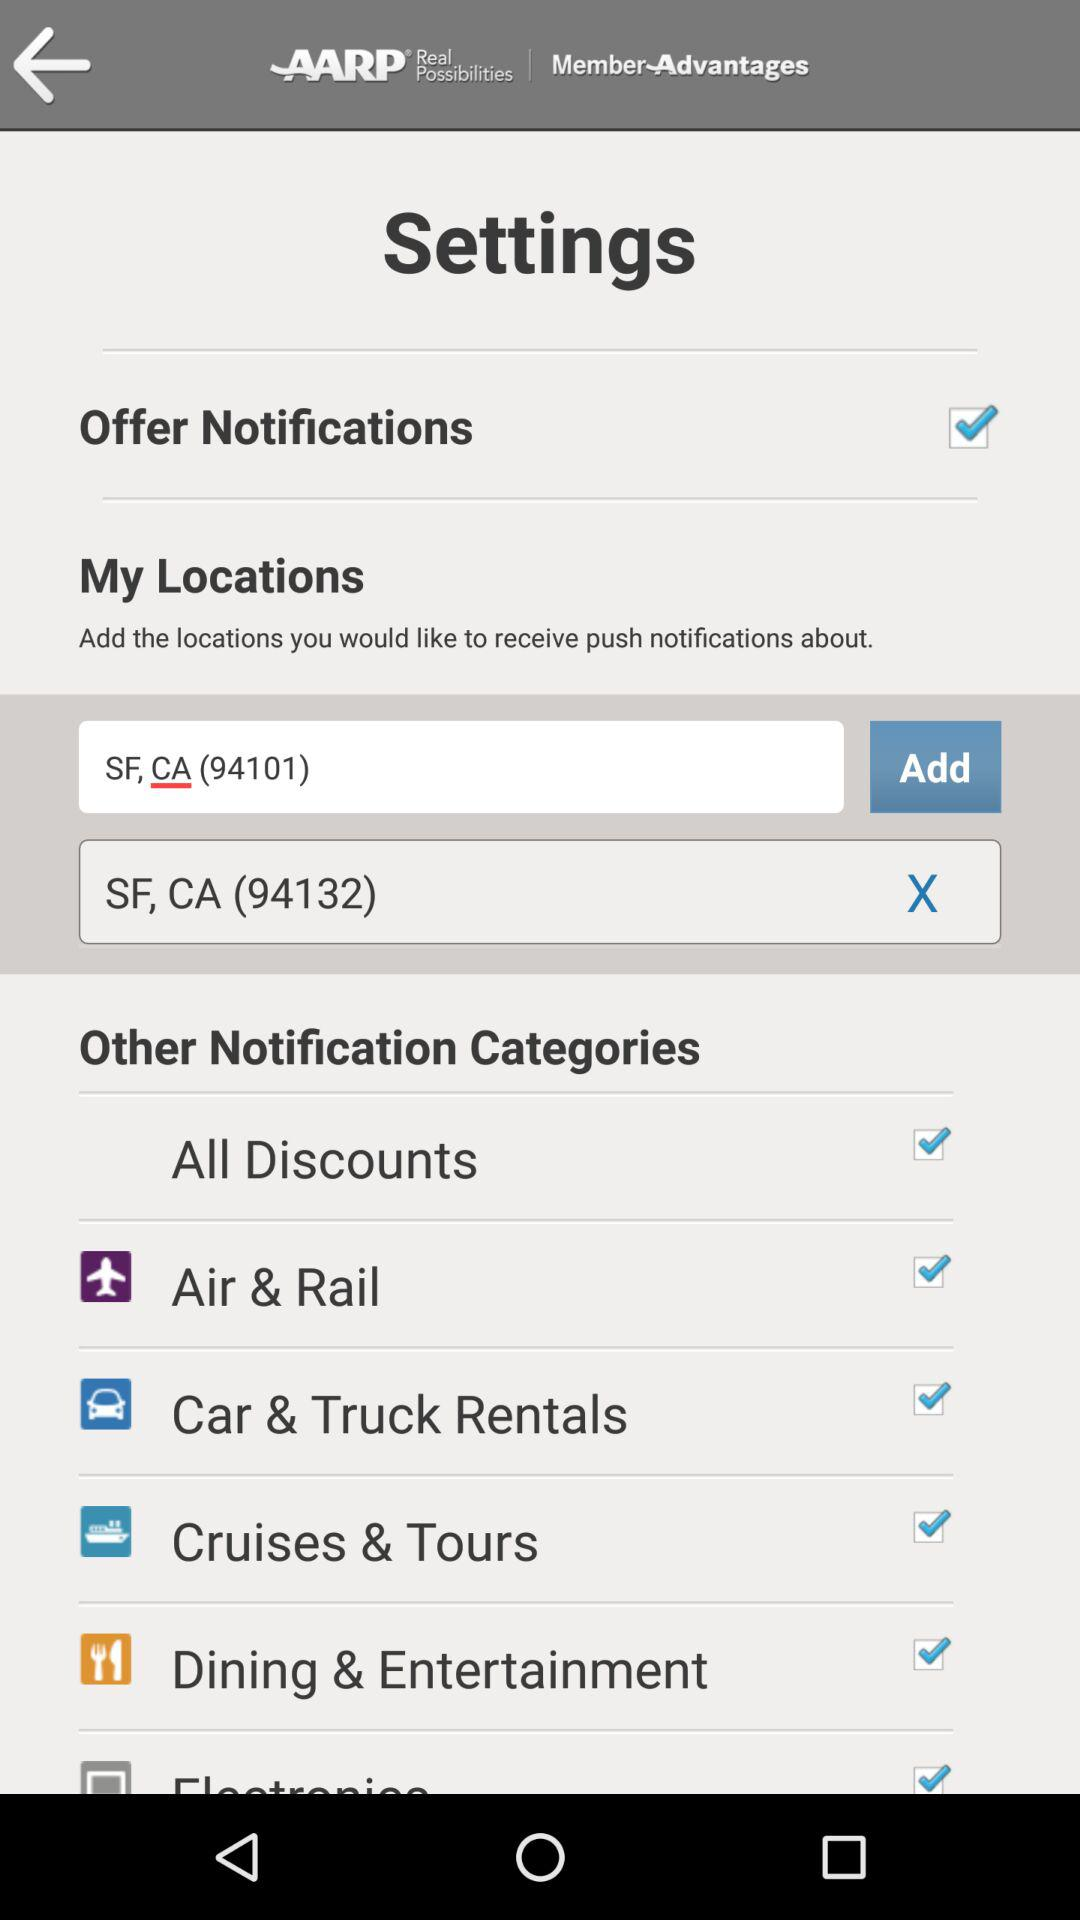What locations are added? The added locations are SF, CA (94101) and SF, CA (94132). 